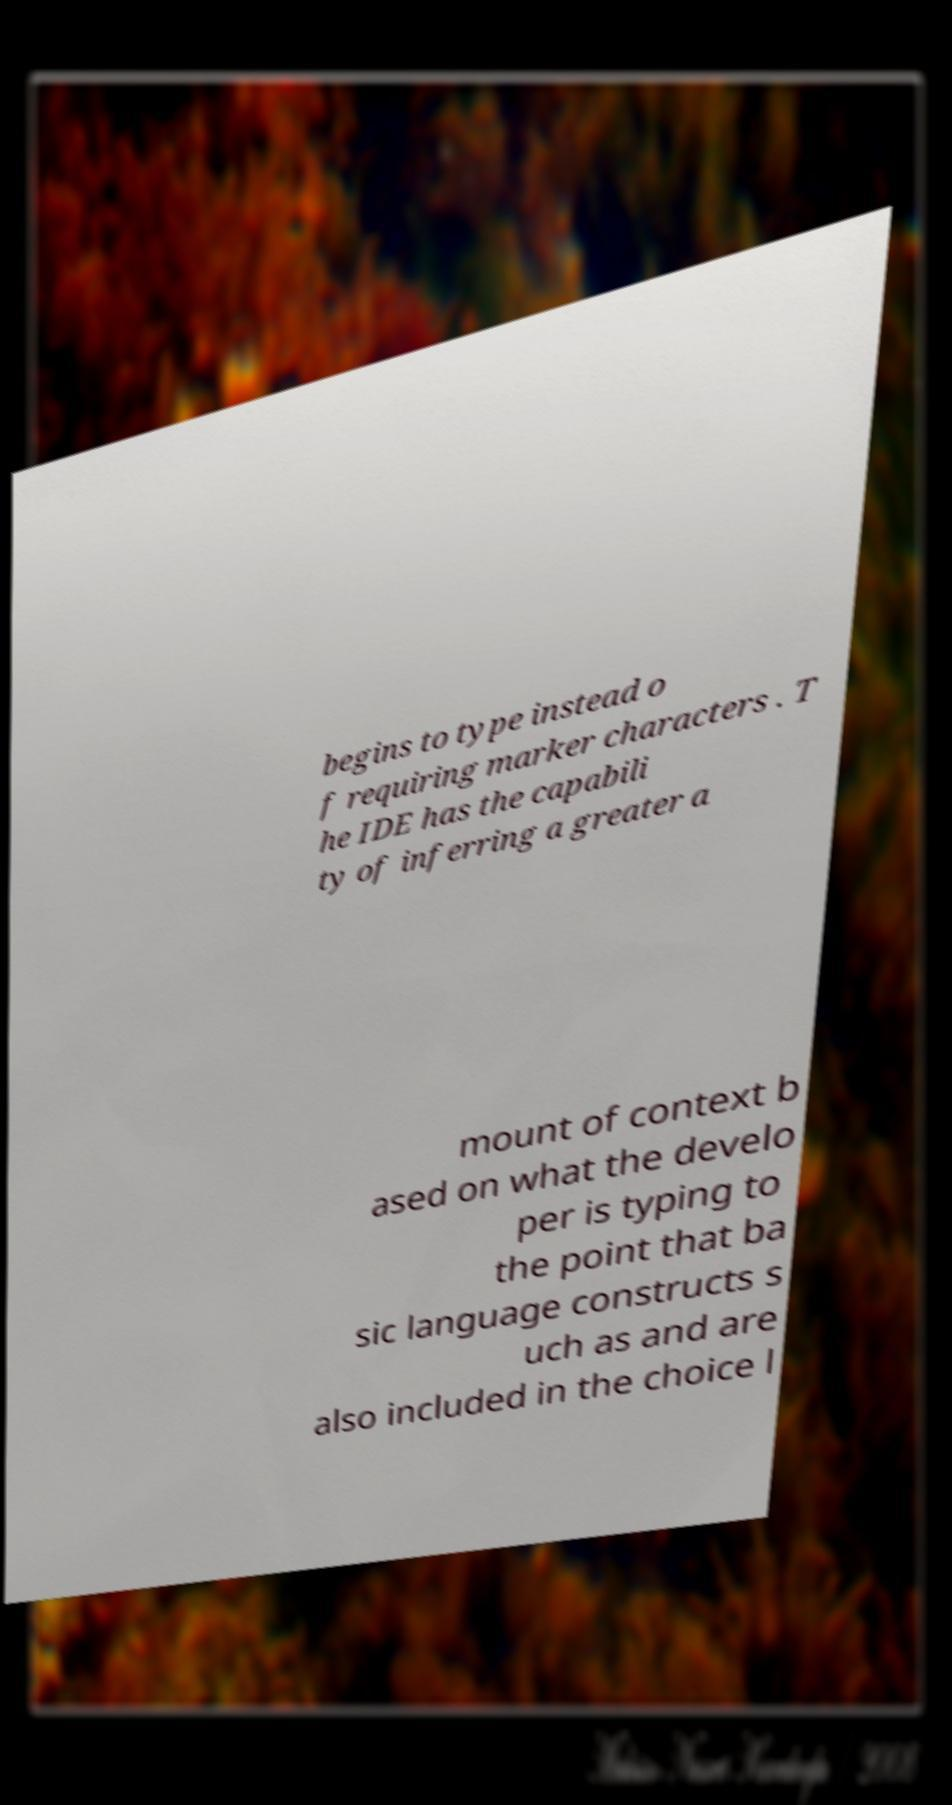I need the written content from this picture converted into text. Can you do that? begins to type instead o f requiring marker characters . T he IDE has the capabili ty of inferring a greater a mount of context b ased on what the develo per is typing to the point that ba sic language constructs s uch as and are also included in the choice l 